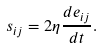<formula> <loc_0><loc_0><loc_500><loc_500>s _ { i j } = 2 \eta \frac { d e _ { i j } } { d t } .</formula> 